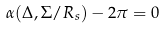Convert formula to latex. <formula><loc_0><loc_0><loc_500><loc_500>\alpha ( \Delta , \Sigma / R _ { s } ) - 2 \pi = 0</formula> 